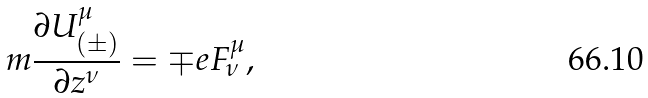Convert formula to latex. <formula><loc_0><loc_0><loc_500><loc_500>m \frac { \partial U _ { ( \pm ) } ^ { \mu } } { \partial z ^ { \nu } } = \mp e F _ { \nu } ^ { \mu } ,</formula> 